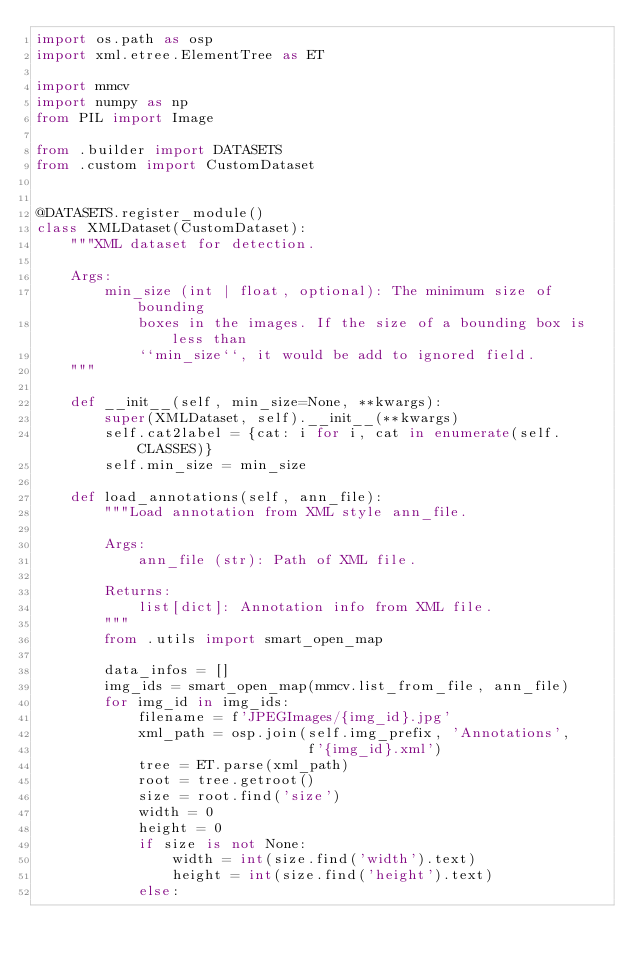Convert code to text. <code><loc_0><loc_0><loc_500><loc_500><_Python_>import os.path as osp
import xml.etree.ElementTree as ET

import mmcv
import numpy as np
from PIL import Image

from .builder import DATASETS
from .custom import CustomDataset


@DATASETS.register_module()
class XMLDataset(CustomDataset):
    """XML dataset for detection.

    Args:
        min_size (int | float, optional): The minimum size of bounding
            boxes in the images. If the size of a bounding box is less than
            ``min_size``, it would be add to ignored field.
    """

    def __init__(self, min_size=None, **kwargs):
        super(XMLDataset, self).__init__(**kwargs)
        self.cat2label = {cat: i for i, cat in enumerate(self.CLASSES)}
        self.min_size = min_size

    def load_annotations(self, ann_file):
        """Load annotation from XML style ann_file.

        Args:
            ann_file (str): Path of XML file.

        Returns:
            list[dict]: Annotation info from XML file.
        """
        from .utils import smart_open_map

        data_infos = []
        img_ids = smart_open_map(mmcv.list_from_file, ann_file)
        for img_id in img_ids:
            filename = f'JPEGImages/{img_id}.jpg'
            xml_path = osp.join(self.img_prefix, 'Annotations',
                                f'{img_id}.xml')
            tree = ET.parse(xml_path)
            root = tree.getroot()
            size = root.find('size')
            width = 0
            height = 0
            if size is not None:
                width = int(size.find('width').text)
                height = int(size.find('height').text)
            else:</code> 